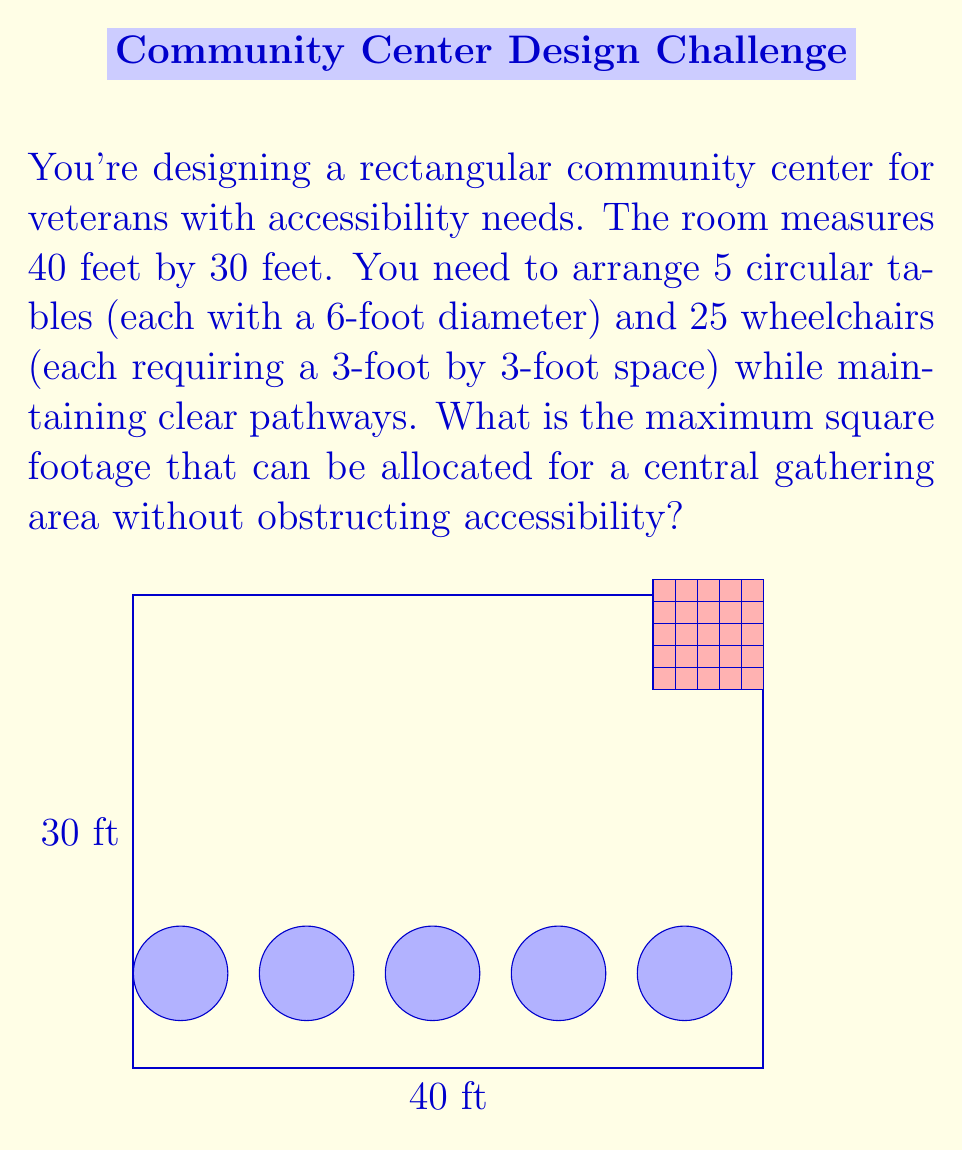Can you solve this math problem? Let's approach this step-by-step:

1) First, calculate the total area of the room:
   $$ \text{Room Area} = 40 \text{ ft} \times 30 \text{ ft} = 1200 \text{ sq ft} $$

2) Calculate the area occupied by tables:
   $$ \text{Table Area} = 5 \times \pi r^2 = 5 \times \pi (3\text{ ft})^2 \approx 141.37 \text{ sq ft} $$

3) Calculate the area occupied by wheelchairs:
   $$ \text{Wheelchair Area} = 25 \times (3\text{ ft} \times 3\text{ ft}) = 225 \text{ sq ft} $$

4) We need to account for pathways. Let's assume we need 3-foot wide pathways along the perimeter and between furniture:
   $$ \text{Pathway Area} = (2 \times 40 \text{ ft} + 2 \times 30 \text{ ft}) \times 3 \text{ ft} = 420 \text{ sq ft} $$

5) Calculate the total occupied area:
   $$ \text{Occupied Area} = 141.37 + 225 + 420 = 786.37 \text{ sq ft} $$

6) The remaining area can be used for the central gathering space:
   $$ \text{Gathering Area} = 1200 \text{ sq ft} - 786.37 \text{ sq ft} = 413.63 \text{ sq ft} $$

Therefore, the maximum square footage that can be allocated for a central gathering area is approximately 413.63 sq ft.
Answer: 413.63 sq ft 